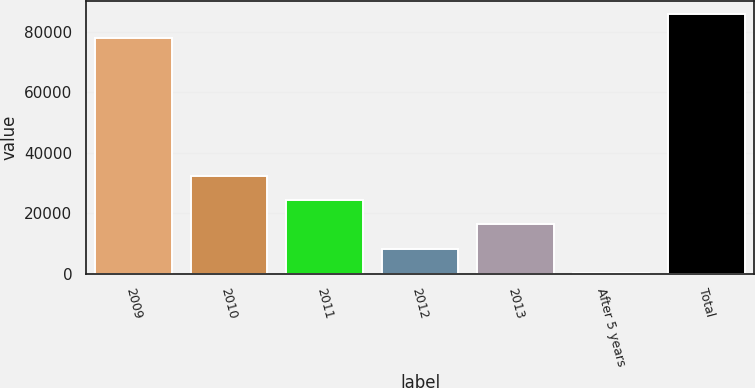<chart> <loc_0><loc_0><loc_500><loc_500><bar_chart><fcel>2009<fcel>2010<fcel>2011<fcel>2012<fcel>2013<fcel>After 5 years<fcel>Total<nl><fcel>77934<fcel>32472<fcel>24410.5<fcel>8287.5<fcel>16349<fcel>226<fcel>85995.5<nl></chart> 